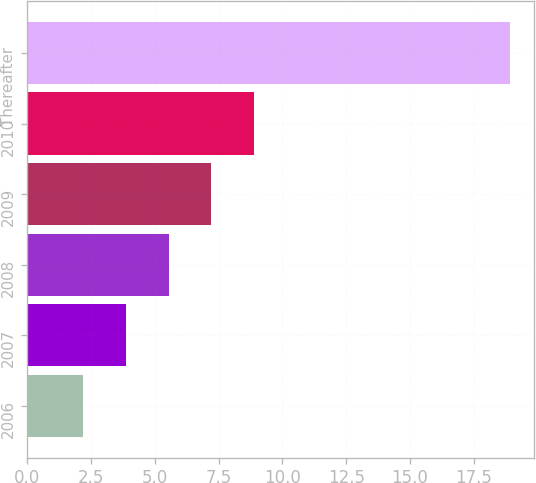<chart> <loc_0><loc_0><loc_500><loc_500><bar_chart><fcel>2006<fcel>2007<fcel>2008<fcel>2009<fcel>2010<fcel>Thereafter<nl><fcel>2.2<fcel>3.87<fcel>5.54<fcel>7.21<fcel>8.88<fcel>18.9<nl></chart> 